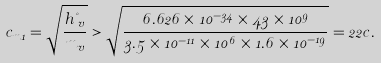Convert formula to latex. <formula><loc_0><loc_0><loc_500><loc_500>c _ { m 1 } = \sqrt { \frac { h \nu _ { v } } { m _ { v } } } > \sqrt { \frac { 6 . 6 2 6 \times 1 0 ^ { - 3 4 } \times 4 3 \times 1 0 ^ { 9 } } { 3 . 5 \times 1 0 ^ { - 1 1 } \times 1 0 ^ { 6 } \times 1 . 6 \times 1 0 ^ { - 1 9 } } } = 2 2 c .</formula> 